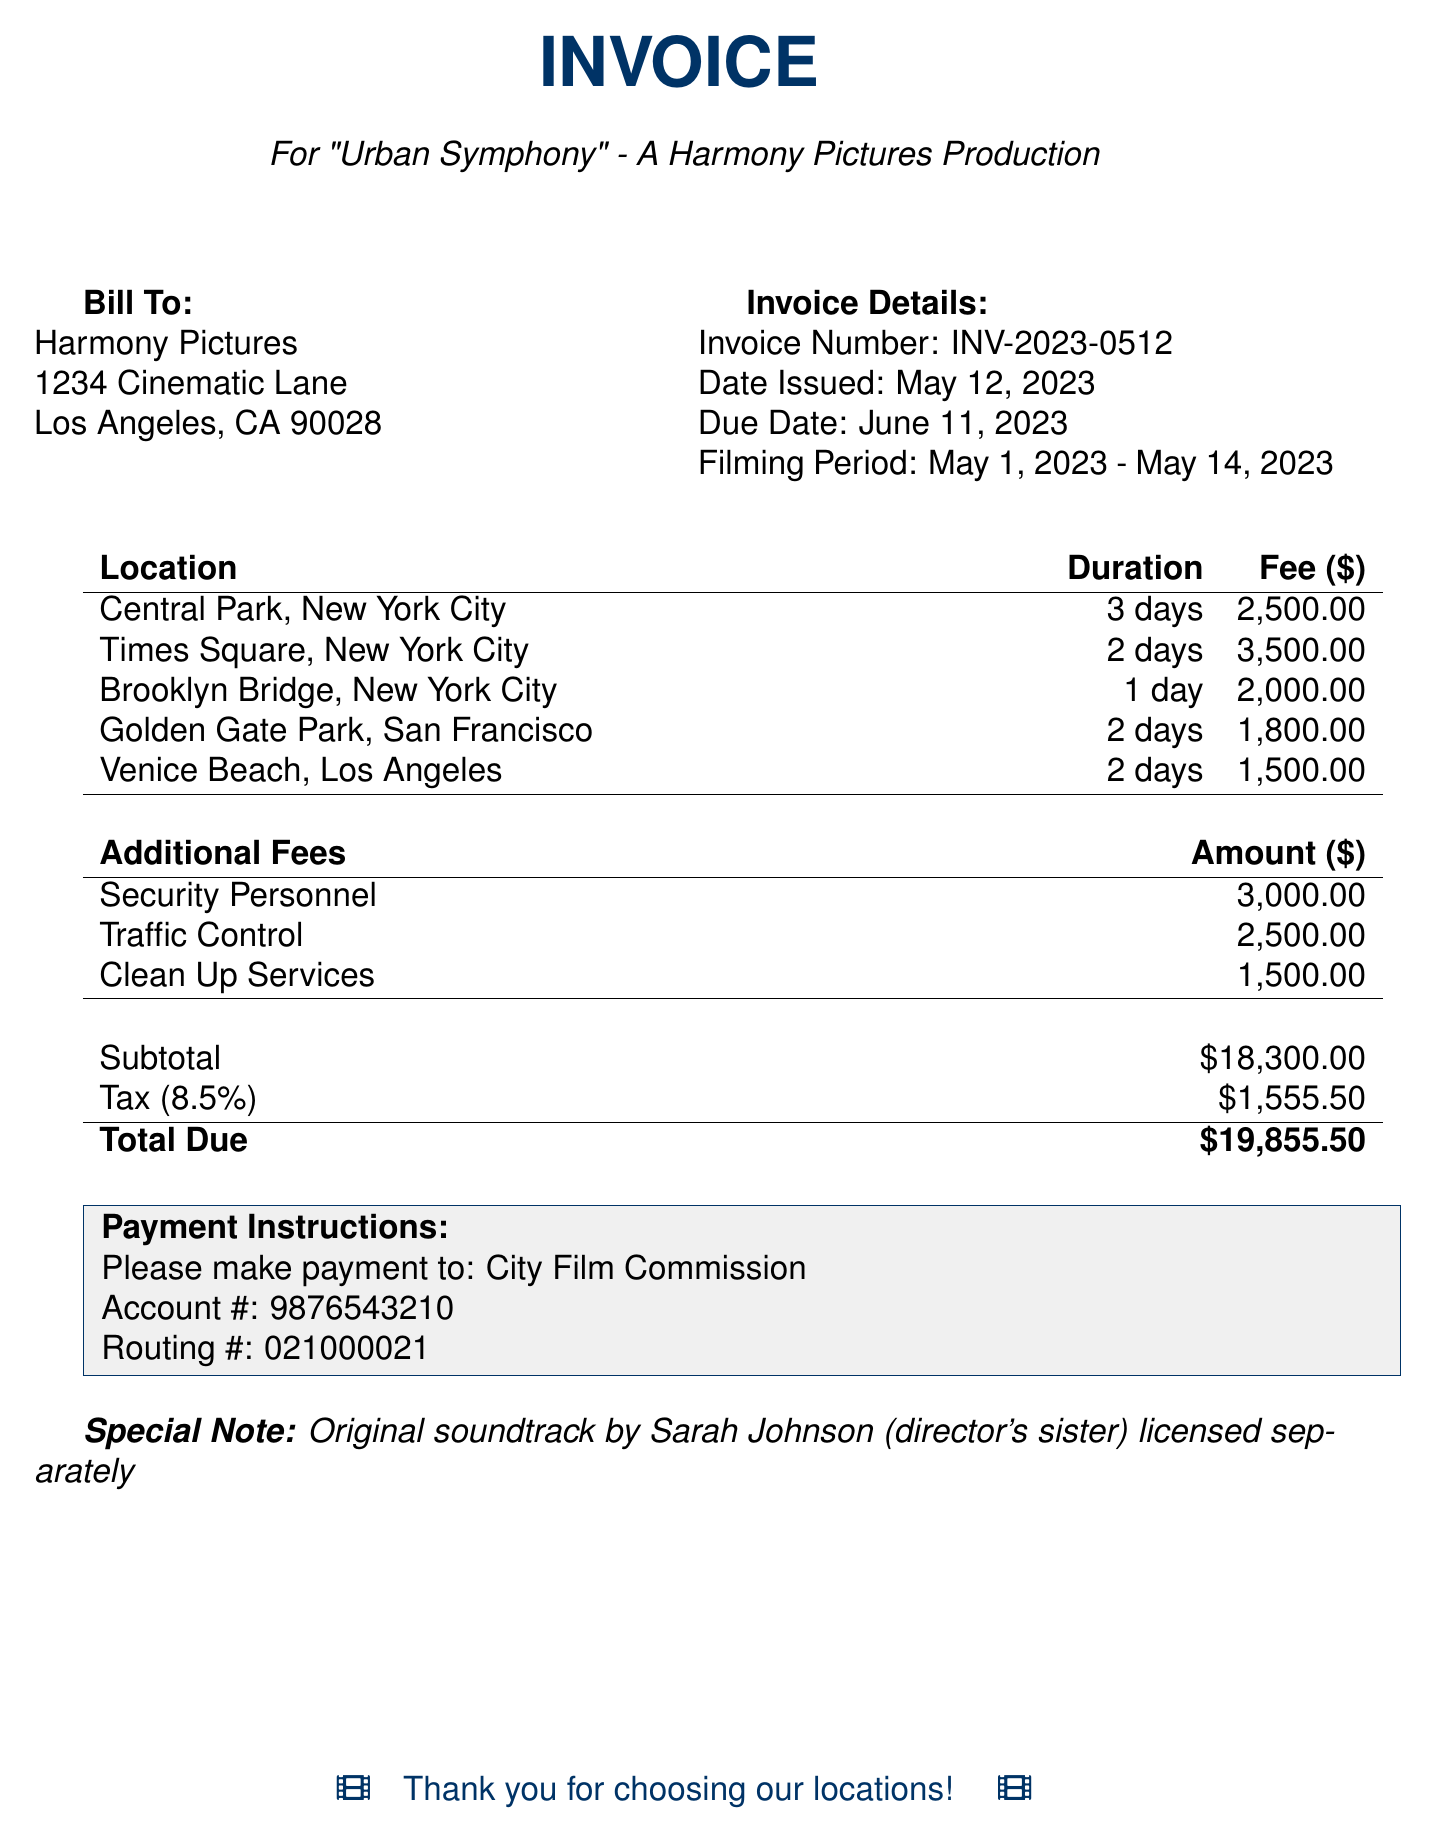What is the invoice number? The invoice number is specified in the document for reference.
Answer: INV-2023-0512 What is the due date for payment? The due date is indicated clearly in the invoice details section.
Answer: June 11, 2023 How many days were spent filming at Central Park? The duration for filming at Central Park is outlined in the location table.
Answer: 3 days What is the total due amount? The document summarizes the total payment that is required at the end.
Answer: $19,855.50 What type of additional fee is included for security? The document lists specific additional fees required.
Answer: Security Personnel What is the tax percentage applied to the subtotal? The tax percentage is explicitly mentioned in the calculation of total due.
Answer: 8.5% Which city has the filming location of Venice Beach? The document specifies the city associated with each filming location.
Answer: Los Angeles How much was the fee for filming at Times Square? The fee for filming at Times Square is provided in the location fee table.
Answer: $3,500.00 What is the name of the original soundtrack artist? The name of the artist is mentioned toward the bottom of the document.
Answer: Sarah Johnson 